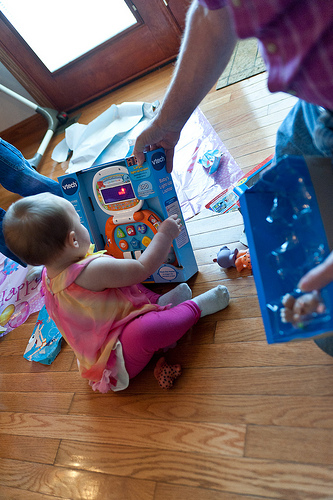<image>
Can you confirm if the toy is in the box? Yes. The toy is contained within or inside the box, showing a containment relationship. 